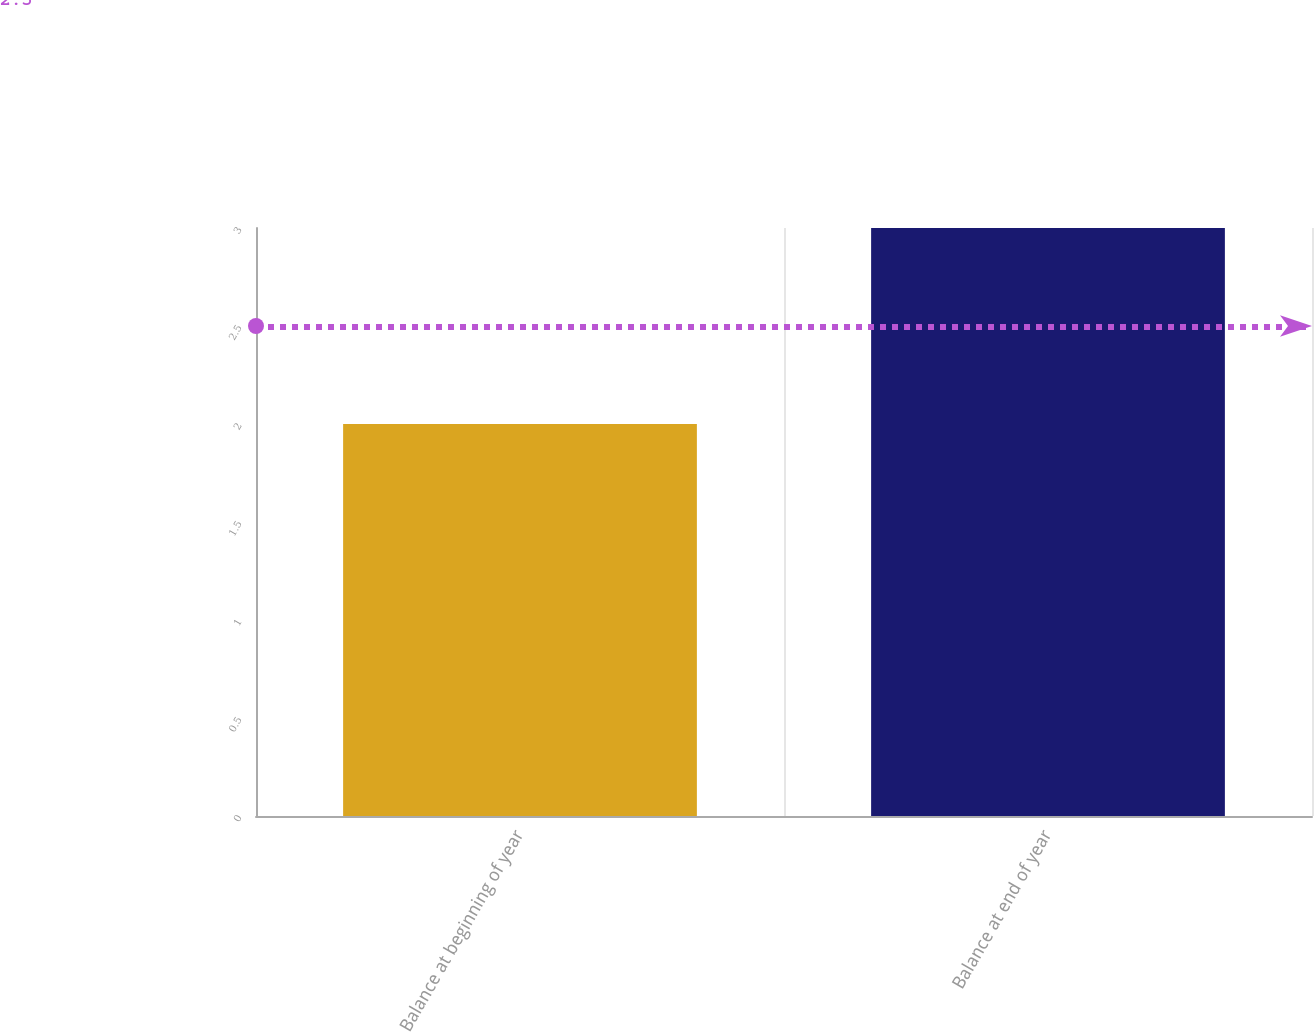Convert chart. <chart><loc_0><loc_0><loc_500><loc_500><bar_chart><fcel>Balance at beginning of year<fcel>Balance at end of year<nl><fcel>2<fcel>3<nl></chart> 